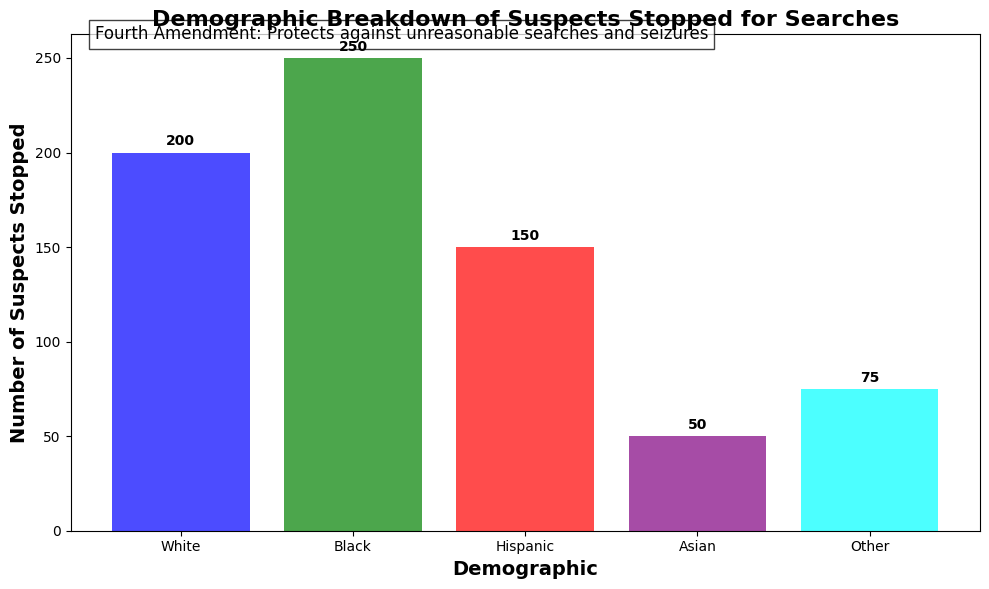Which demographic group had the highest number of suspects stopped? The figure shows bars representing the number of suspects stopped for each demographic group. The highest bar represents the Black demographic with 250 suspects.
Answer: Black Which two demographic groups had the lowest number of suspects stopped combined? The figure shows that the Asian group has 50 suspects, and the Other group has 75 suspects. Combining these gives 50+75 = 125, which is the lowest compared to other combinations.
Answer: Asian and Other What is the total number of suspects stopped across all demographic groups? Add the heights of all bars to find the total: 200 (White) + 250 (Black) + 150 (Hispanic) + 50 (Asian) + 75 (Other). This sums up to 725.
Answer: 725 How many more suspects were stopped from the Black demographic compared to the Hispanic demographic? Subtract the number of Hispanic suspects from the number of Black suspects: 250 - 150 = 100.
Answer: 100 What percentage of the total suspects stopped were White? First, find the total number of suspects stopped, which is 725. Then, the number of White suspects is 200. The percentage is calculated as (200/725) * 100 ≈ 27.59%.
Answer: ~27.59% What is the average number of suspects stopped per demographic group? Divide the total number of suspects stopped (725) by the number of demographic groups (5). The average is 725 / 5 = 145.
Answer: 145 Which demographic group has less than half the number of suspects stopped as the Black demographic? Half of the number stopped in the Black demographic is 250 / 2 = 125. Both the Asian (50) and Other (75) groups have less than 125 suspects stopped.
Answer: Asian and Other What visual note is included in the figure’s annotation? The annotation text in the figure states "Fourth Amendment: Protects against unreasonable searches and seizures." This note is written at the top left of the chart.
Answer: Fourth Amendment: Protects against unreasonable searches and seizures By how much does the number of suspects stopped in the Black demographic exceed the average number of suspects stopped per demographic group? The average number of suspects stopped is 145. The Black demographic has 250 suspects stopped. The difference is 250 - 145 = 105.
Answer: 105 